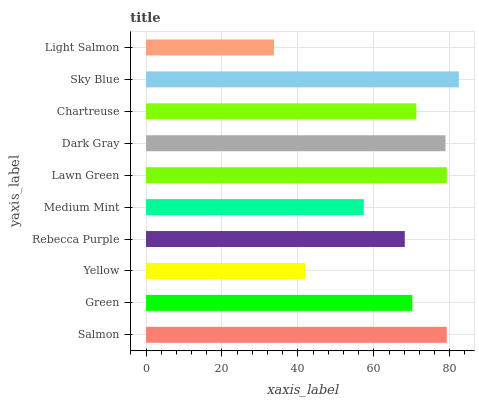Is Light Salmon the minimum?
Answer yes or no. Yes. Is Sky Blue the maximum?
Answer yes or no. Yes. Is Green the minimum?
Answer yes or no. No. Is Green the maximum?
Answer yes or no. No. Is Salmon greater than Green?
Answer yes or no. Yes. Is Green less than Salmon?
Answer yes or no. Yes. Is Green greater than Salmon?
Answer yes or no. No. Is Salmon less than Green?
Answer yes or no. No. Is Chartreuse the high median?
Answer yes or no. Yes. Is Green the low median?
Answer yes or no. Yes. Is Light Salmon the high median?
Answer yes or no. No. Is Light Salmon the low median?
Answer yes or no. No. 